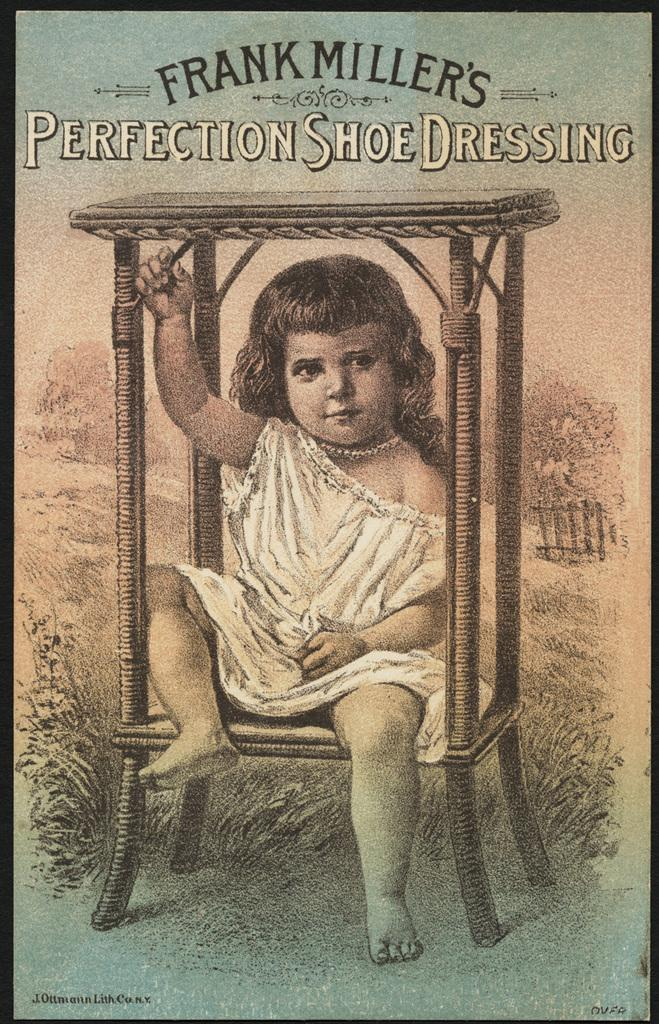What is the main object in the image? There is a banner in the image. What is depicted on the banner? The banner has a painting of a child wearing a white dress. What can be seen in the background of the painting? There is grass and trees depicted in the painting. Is there any text on the banner? Yes, there is text written on the banner. How many roses are being held by the person in the image? There is no person present in the image, and therefore no roses can be held by a person. Is there an umbrella visible in the painting on the banner? There is no umbrella depicted in the painting on the banner. 